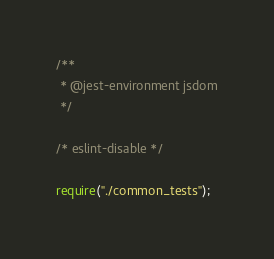Convert code to text. <code><loc_0><loc_0><loc_500><loc_500><_JavaScript_>/**
 * @jest-environment jsdom
 */

/* eslint-disable */

require("./common_tests");
</code> 